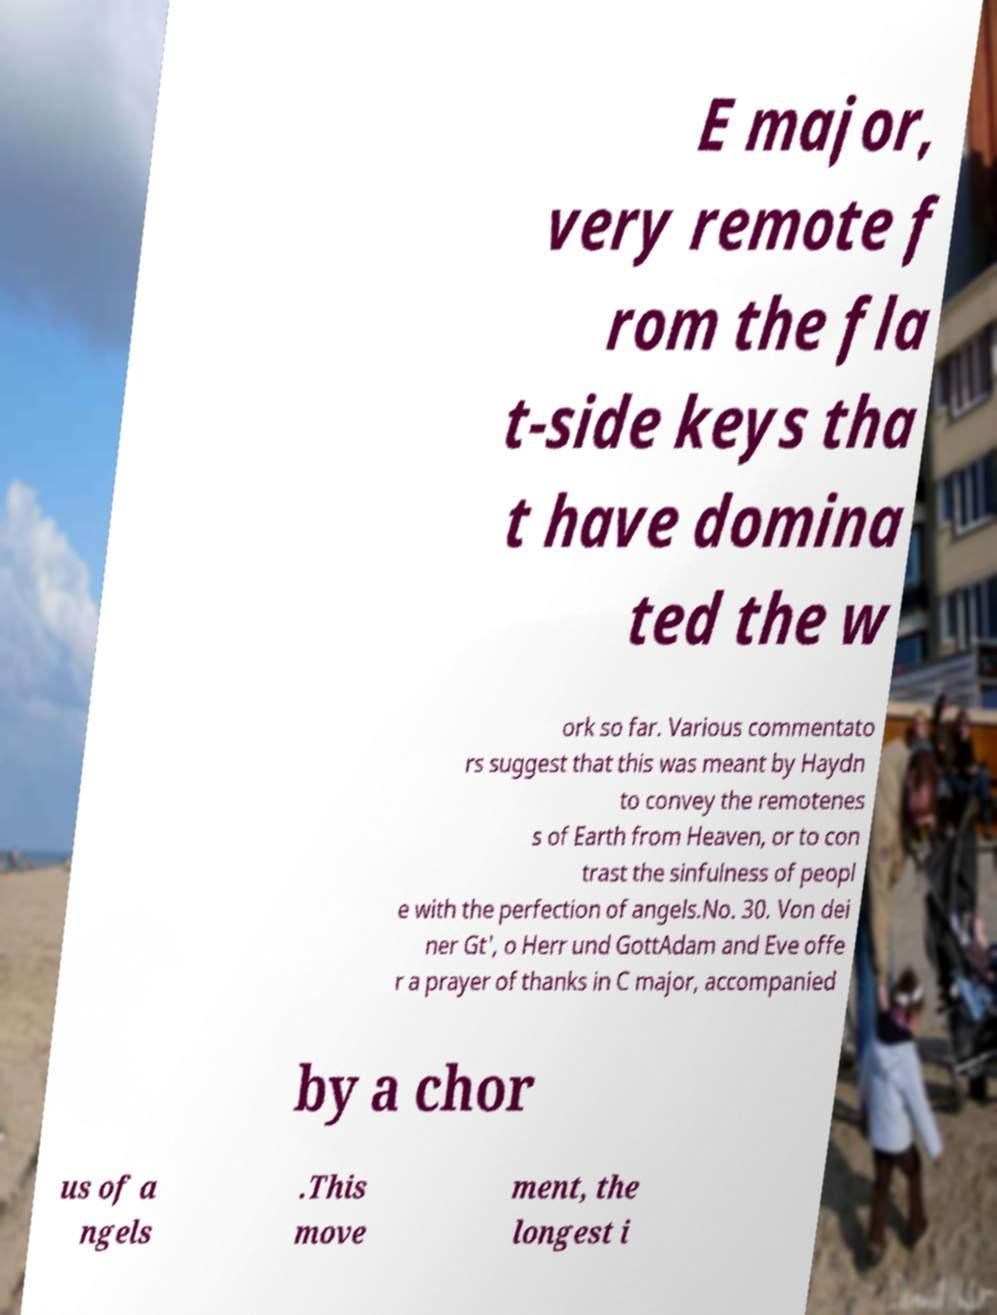What messages or text are displayed in this image? I need them in a readable, typed format. E major, very remote f rom the fla t-side keys tha t have domina ted the w ork so far. Various commentato rs suggest that this was meant by Haydn to convey the remotenes s of Earth from Heaven, or to con trast the sinfulness of peopl e with the perfection of angels.No. 30. Von dei ner Gt', o Herr und GottAdam and Eve offe r a prayer of thanks in C major, accompanied by a chor us of a ngels .This move ment, the longest i 